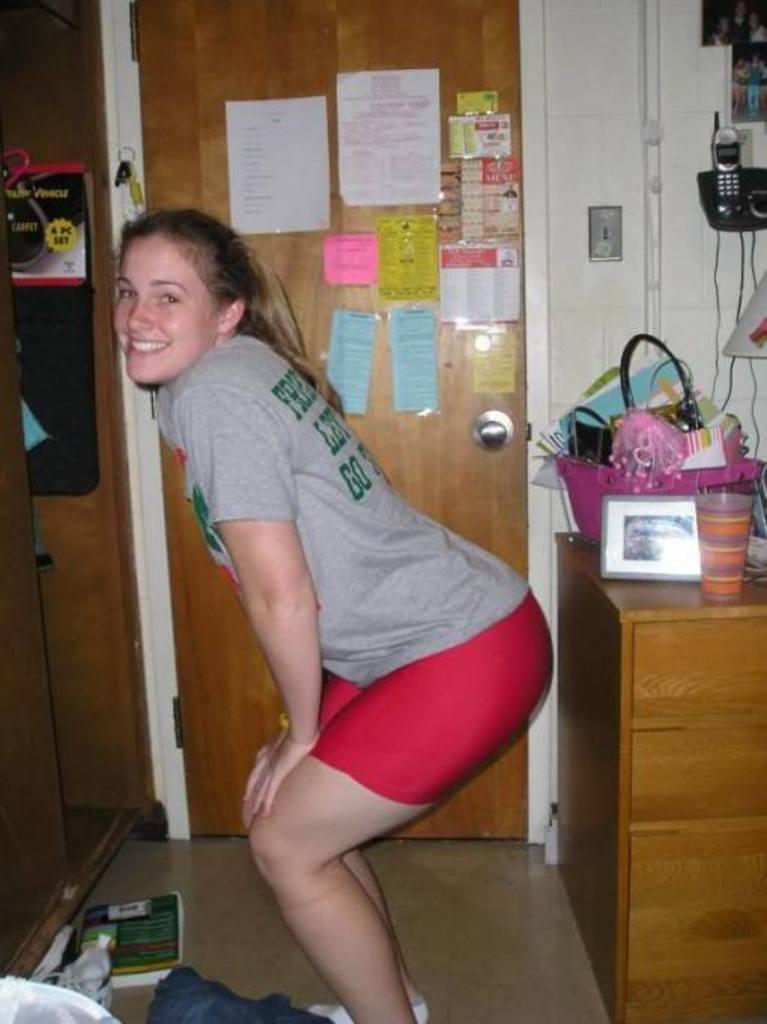How would you summarize this image in a sentence or two? This picture is clicked inside the city. The woman in the middle of the picture is standing and she is posing for the photo. She is smiling. Behind her, we see a wooden table on which glass, photo frame and a pink basket containing some objects are placed. Beside that, we see a white wall on which photo frame and telephone are placed. Beside that, we see a door on which many posts are posted. On the left side, we see wooden door. At the bottom, we see a blue color cloth and a book. 